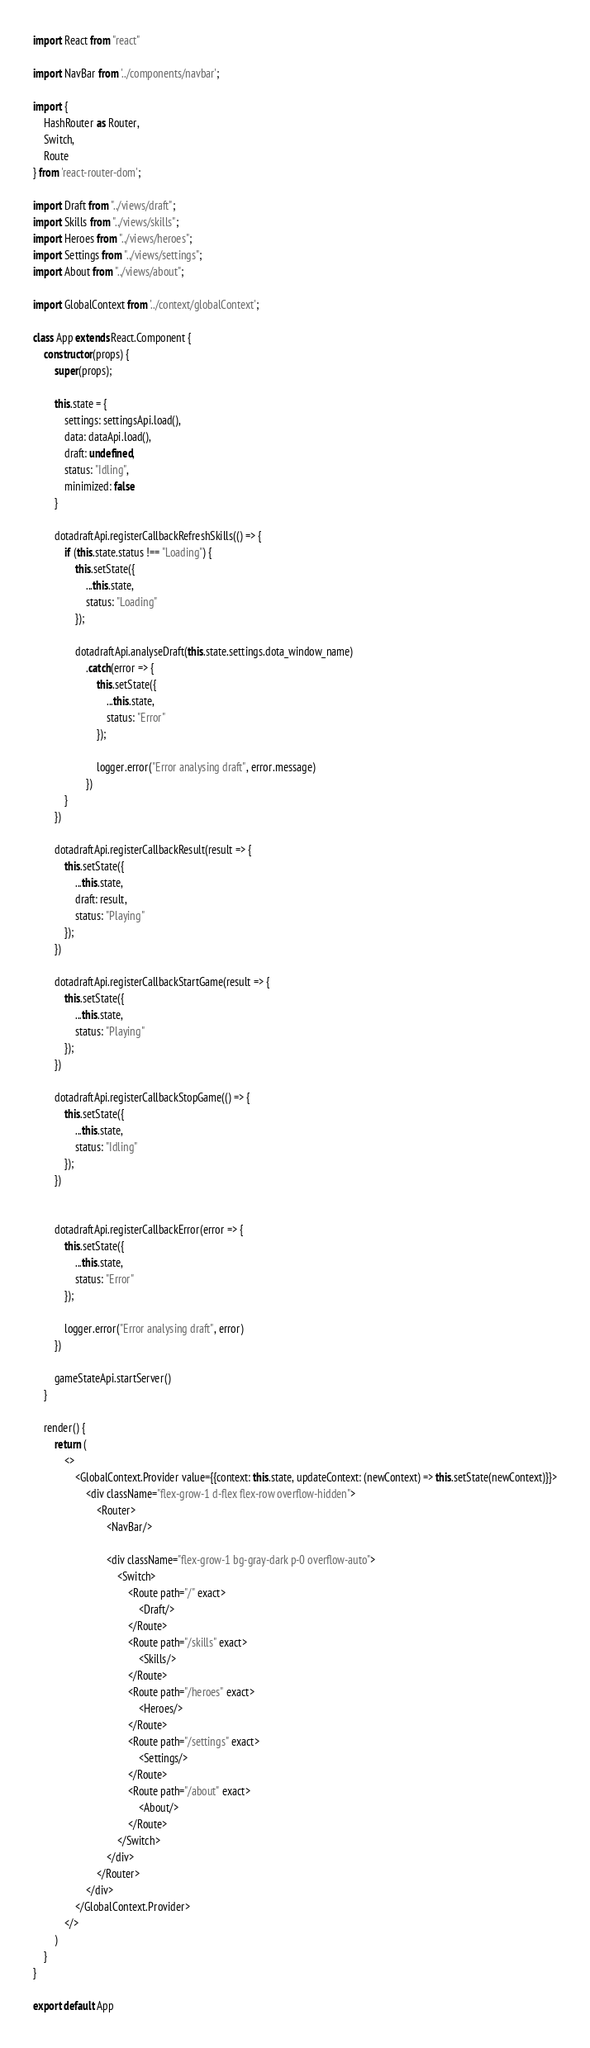Convert code to text. <code><loc_0><loc_0><loc_500><loc_500><_JavaScript_>import React from "react"

import NavBar from '../components/navbar';

import {
    HashRouter as Router,
    Switch,
    Route
} from 'react-router-dom';

import Draft from "../views/draft";
import Skills from "../views/skills";
import Heroes from "../views/heroes";
import Settings from "../views/settings";
import About from "../views/about";

import GlobalContext from '../context/globalContext';

class App extends React.Component {
    constructor(props) {
        super(props);

        this.state = {
            settings: settingsApi.load(),
            data: dataApi.load(),
            draft: undefined,
            status: "Idling",
            minimized: false
        }

        dotadraftApi.registerCallbackRefreshSkills(() => {
            if (this.state.status !== "Loading") {
                this.setState({
                    ...this.state,
                    status: "Loading"
                });

                dotadraftApi.analyseDraft(this.state.settings.dota_window_name)
                    .catch(error => {
                        this.setState({
                            ...this.state,
                            status: "Error"
                        });

                        logger.error("Error analysing draft", error.message)
                    })
            }
        })

        dotadraftApi.registerCallbackResult(result => {
            this.setState({
                ...this.state,
                draft: result,
                status: "Playing"
            });
        })

        dotadraftApi.registerCallbackStartGame(result => {
            this.setState({
                ...this.state,
                status: "Playing"
            });
        })

        dotadraftApi.registerCallbackStopGame(() => {
            this.setState({
                ...this.state,
                status: "Idling"
            });
        })


        dotadraftApi.registerCallbackError(error => {
            this.setState({
                ...this.state,
                status: "Error"
            });

            logger.error("Error analysing draft", error)
        })

        gameStateApi.startServer()
    }

    render() {
        return (
            <>
                <GlobalContext.Provider value={{context: this.state, updateContext: (newContext) => this.setState(newContext)}}>
                    <div className="flex-grow-1 d-flex flex-row overflow-hidden">
                        <Router>
                            <NavBar/>

                            <div className="flex-grow-1 bg-gray-dark p-0 overflow-auto">
                                <Switch>
                                    <Route path="/" exact>
                                        <Draft/>
                                    </Route>
                                    <Route path="/skills" exact>
                                        <Skills/>
                                    </Route>
                                    <Route path="/heroes" exact>
                                        <Heroes/>
                                    </Route>
                                    <Route path="/settings" exact>
                                        <Settings/>
                                    </Route>
                                    <Route path="/about" exact>
                                        <About/>
                                    </Route>
                                </Switch>
                            </div>
                        </Router>
                    </div>
                </GlobalContext.Provider>
            </>
        )
    }
}

export default App</code> 